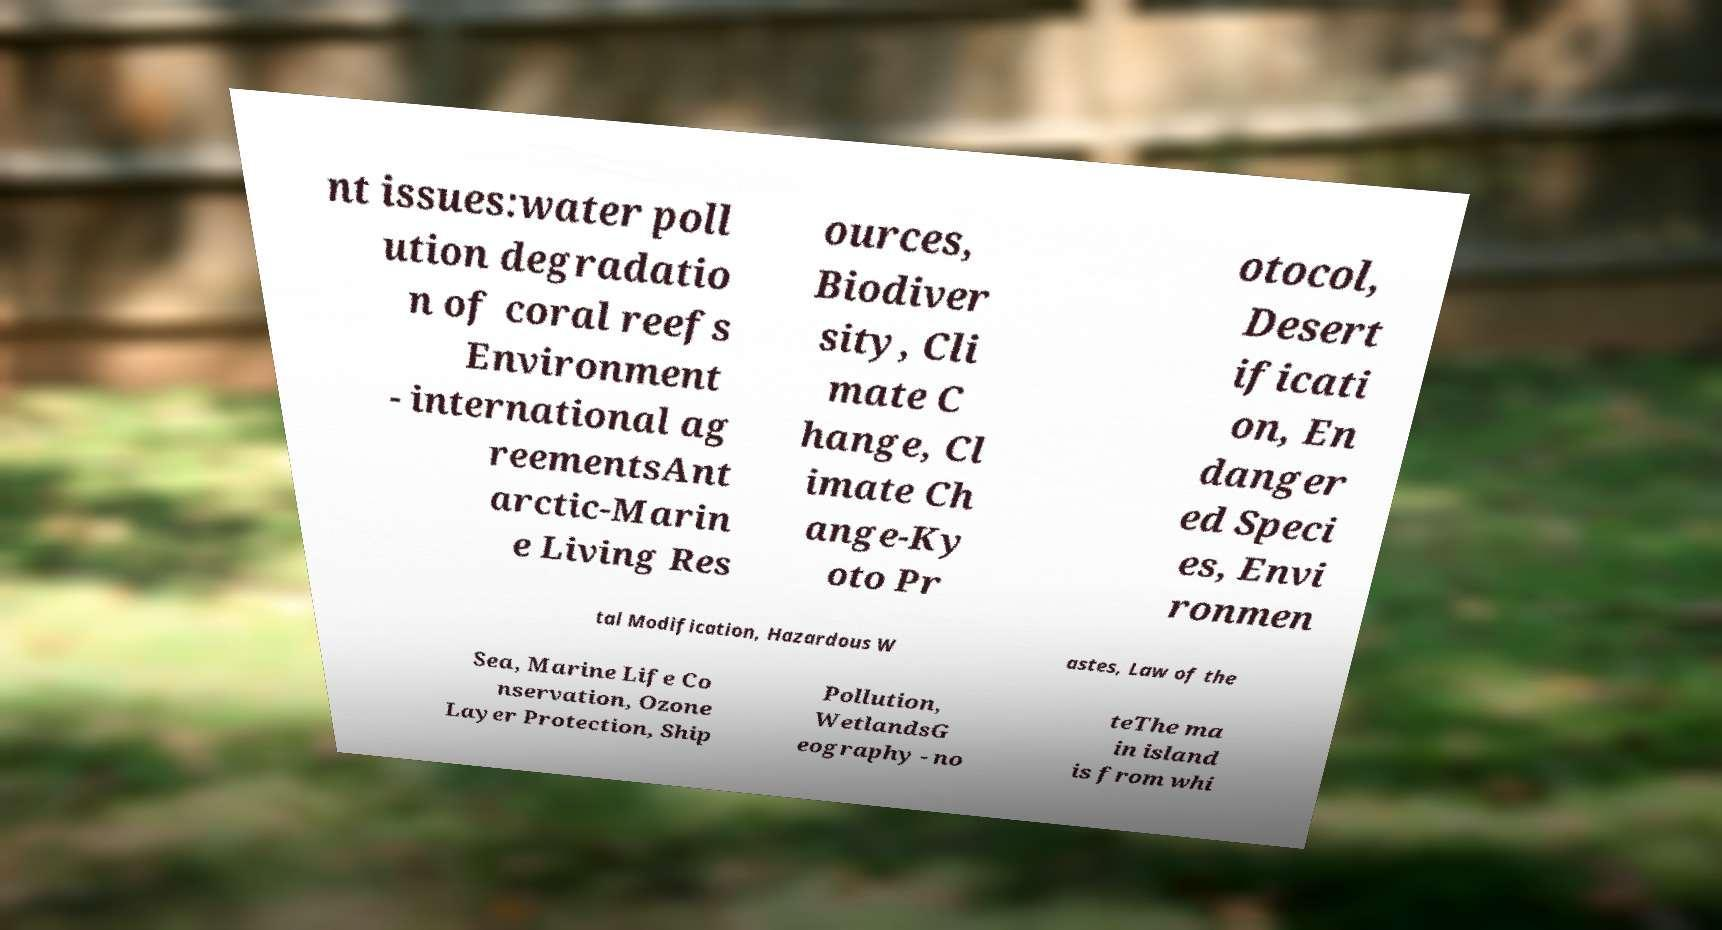I need the written content from this picture converted into text. Can you do that? nt issues:water poll ution degradatio n of coral reefs Environment - international ag reementsAnt arctic-Marin e Living Res ources, Biodiver sity, Cli mate C hange, Cl imate Ch ange-Ky oto Pr otocol, Desert ificati on, En danger ed Speci es, Envi ronmen tal Modification, Hazardous W astes, Law of the Sea, Marine Life Co nservation, Ozone Layer Protection, Ship Pollution, WetlandsG eography - no teThe ma in island is from whi 